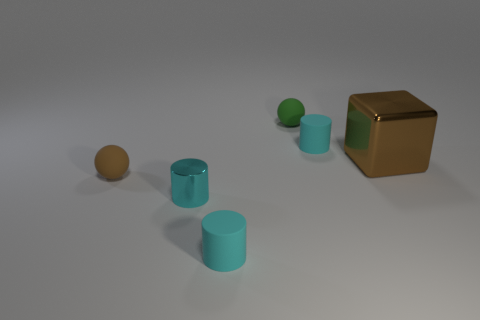Can you describe the objects arranged on the surface and their colors? The image features a variety of simple geometric objects arranged on a flat surface. Starting from the left, there is a ball with a tan color, followed by three cylinders that appear to be made of rubber, each in a shade of teal or light blue. On the far right, there is a brown cube, accompanied by a small sphere in a green hue that mirrors the shade of the cylinders. 